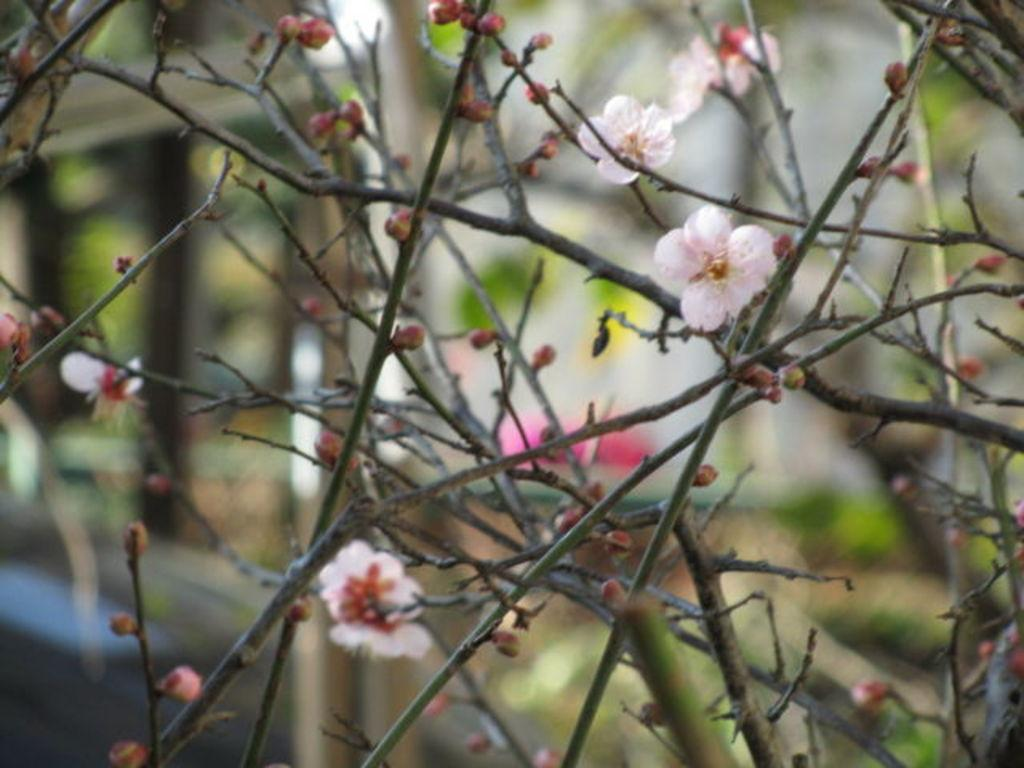What type of plant elements can be seen in the image? There are branches and flowers in the image. Can you describe the background of the image? The background of the image is blurry. What type of animals can be seen at the zoo in the image? There is no zoo or animals present in the image; it features branches and flowers. How does the twist in the branch affect the overall composition of the image? There is no twist in the branch mentioned in the facts, so it cannot affect the composition of the image. 